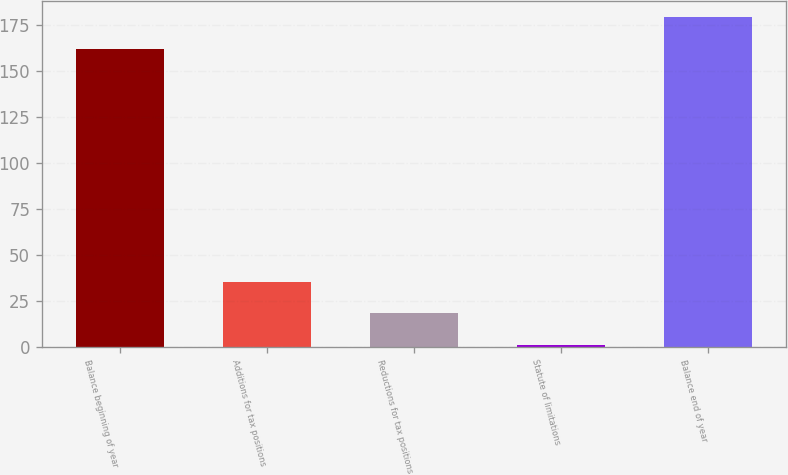Convert chart to OTSL. <chart><loc_0><loc_0><loc_500><loc_500><bar_chart><fcel>Balance beginning of year<fcel>Additions for tax positions<fcel>Reductions for tax positions<fcel>Statute of limitations<fcel>Balance end of year<nl><fcel>162<fcel>35.4<fcel>18.2<fcel>1<fcel>179.2<nl></chart> 